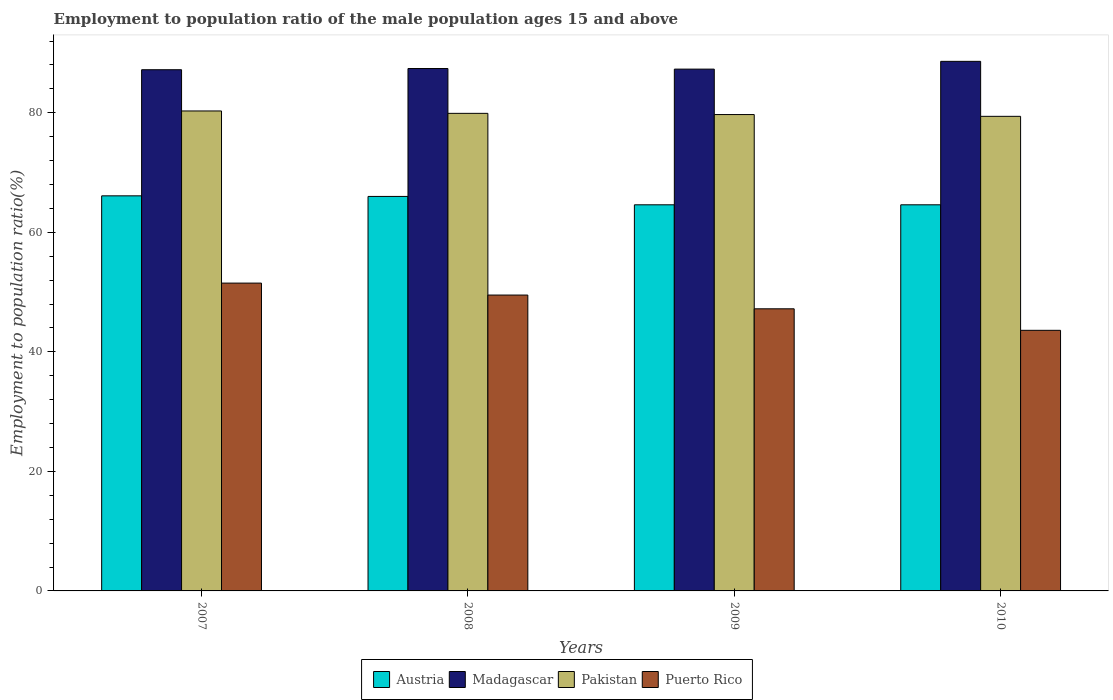How many bars are there on the 2nd tick from the left?
Provide a short and direct response. 4. How many bars are there on the 2nd tick from the right?
Keep it short and to the point. 4. In how many cases, is the number of bars for a given year not equal to the number of legend labels?
Provide a short and direct response. 0. What is the employment to population ratio in Pakistan in 2008?
Keep it short and to the point. 79.9. Across all years, what is the maximum employment to population ratio in Puerto Rico?
Ensure brevity in your answer.  51.5. Across all years, what is the minimum employment to population ratio in Madagascar?
Your answer should be very brief. 87.2. In which year was the employment to population ratio in Madagascar maximum?
Your answer should be compact. 2010. What is the total employment to population ratio in Austria in the graph?
Your answer should be compact. 261.3. What is the difference between the employment to population ratio in Madagascar in 2007 and that in 2008?
Your response must be concise. -0.2. What is the difference between the employment to population ratio in Pakistan in 2008 and the employment to population ratio in Madagascar in 2009?
Provide a succinct answer. -7.4. What is the average employment to population ratio in Puerto Rico per year?
Ensure brevity in your answer.  47.95. In the year 2010, what is the difference between the employment to population ratio in Puerto Rico and employment to population ratio in Pakistan?
Your answer should be compact. -35.8. What is the ratio of the employment to population ratio in Pakistan in 2007 to that in 2008?
Your answer should be very brief. 1.01. Is the employment to population ratio in Austria in 2007 less than that in 2010?
Keep it short and to the point. No. What is the difference between the highest and the second highest employment to population ratio in Puerto Rico?
Your answer should be compact. 2. What is the difference between the highest and the lowest employment to population ratio in Pakistan?
Provide a succinct answer. 0.9. In how many years, is the employment to population ratio in Pakistan greater than the average employment to population ratio in Pakistan taken over all years?
Provide a short and direct response. 2. Is the sum of the employment to population ratio in Madagascar in 2008 and 2009 greater than the maximum employment to population ratio in Pakistan across all years?
Your answer should be very brief. Yes. What does the 3rd bar from the right in 2010 represents?
Provide a short and direct response. Madagascar. Are all the bars in the graph horizontal?
Keep it short and to the point. No. How many years are there in the graph?
Your answer should be compact. 4. What is the difference between two consecutive major ticks on the Y-axis?
Your response must be concise. 20. Does the graph contain any zero values?
Offer a terse response. No. Does the graph contain grids?
Provide a short and direct response. No. Where does the legend appear in the graph?
Give a very brief answer. Bottom center. How many legend labels are there?
Provide a succinct answer. 4. What is the title of the graph?
Make the answer very short. Employment to population ratio of the male population ages 15 and above. Does "Low income" appear as one of the legend labels in the graph?
Make the answer very short. No. What is the Employment to population ratio(%) in Austria in 2007?
Your answer should be very brief. 66.1. What is the Employment to population ratio(%) in Madagascar in 2007?
Your answer should be very brief. 87.2. What is the Employment to population ratio(%) of Pakistan in 2007?
Make the answer very short. 80.3. What is the Employment to population ratio(%) of Puerto Rico in 2007?
Provide a short and direct response. 51.5. What is the Employment to population ratio(%) in Madagascar in 2008?
Provide a succinct answer. 87.4. What is the Employment to population ratio(%) in Pakistan in 2008?
Make the answer very short. 79.9. What is the Employment to population ratio(%) in Puerto Rico in 2008?
Your answer should be compact. 49.5. What is the Employment to population ratio(%) of Austria in 2009?
Offer a terse response. 64.6. What is the Employment to population ratio(%) of Madagascar in 2009?
Provide a short and direct response. 87.3. What is the Employment to population ratio(%) in Pakistan in 2009?
Provide a succinct answer. 79.7. What is the Employment to population ratio(%) of Puerto Rico in 2009?
Offer a terse response. 47.2. What is the Employment to population ratio(%) of Austria in 2010?
Your response must be concise. 64.6. What is the Employment to population ratio(%) of Madagascar in 2010?
Your answer should be compact. 88.6. What is the Employment to population ratio(%) of Pakistan in 2010?
Your response must be concise. 79.4. What is the Employment to population ratio(%) of Puerto Rico in 2010?
Provide a short and direct response. 43.6. Across all years, what is the maximum Employment to population ratio(%) of Austria?
Offer a terse response. 66.1. Across all years, what is the maximum Employment to population ratio(%) of Madagascar?
Offer a terse response. 88.6. Across all years, what is the maximum Employment to population ratio(%) of Pakistan?
Give a very brief answer. 80.3. Across all years, what is the maximum Employment to population ratio(%) of Puerto Rico?
Give a very brief answer. 51.5. Across all years, what is the minimum Employment to population ratio(%) of Austria?
Offer a terse response. 64.6. Across all years, what is the minimum Employment to population ratio(%) in Madagascar?
Your response must be concise. 87.2. Across all years, what is the minimum Employment to population ratio(%) in Pakistan?
Ensure brevity in your answer.  79.4. Across all years, what is the minimum Employment to population ratio(%) of Puerto Rico?
Provide a short and direct response. 43.6. What is the total Employment to population ratio(%) in Austria in the graph?
Give a very brief answer. 261.3. What is the total Employment to population ratio(%) of Madagascar in the graph?
Your response must be concise. 350.5. What is the total Employment to population ratio(%) of Pakistan in the graph?
Offer a terse response. 319.3. What is the total Employment to population ratio(%) of Puerto Rico in the graph?
Your response must be concise. 191.8. What is the difference between the Employment to population ratio(%) in Austria in 2007 and that in 2008?
Provide a short and direct response. 0.1. What is the difference between the Employment to population ratio(%) in Pakistan in 2007 and that in 2008?
Ensure brevity in your answer.  0.4. What is the difference between the Employment to population ratio(%) in Austria in 2007 and that in 2010?
Offer a very short reply. 1.5. What is the difference between the Employment to population ratio(%) in Madagascar in 2007 and that in 2010?
Make the answer very short. -1.4. What is the difference between the Employment to population ratio(%) of Puerto Rico in 2007 and that in 2010?
Offer a very short reply. 7.9. What is the difference between the Employment to population ratio(%) in Austria in 2008 and that in 2009?
Provide a succinct answer. 1.4. What is the difference between the Employment to population ratio(%) in Madagascar in 2008 and that in 2009?
Offer a very short reply. 0.1. What is the difference between the Employment to population ratio(%) in Pakistan in 2008 and that in 2009?
Offer a terse response. 0.2. What is the difference between the Employment to population ratio(%) in Austria in 2008 and that in 2010?
Ensure brevity in your answer.  1.4. What is the difference between the Employment to population ratio(%) in Puerto Rico in 2009 and that in 2010?
Provide a short and direct response. 3.6. What is the difference between the Employment to population ratio(%) in Austria in 2007 and the Employment to population ratio(%) in Madagascar in 2008?
Keep it short and to the point. -21.3. What is the difference between the Employment to population ratio(%) of Austria in 2007 and the Employment to population ratio(%) of Pakistan in 2008?
Keep it short and to the point. -13.8. What is the difference between the Employment to population ratio(%) of Austria in 2007 and the Employment to population ratio(%) of Puerto Rico in 2008?
Make the answer very short. 16.6. What is the difference between the Employment to population ratio(%) in Madagascar in 2007 and the Employment to population ratio(%) in Puerto Rico in 2008?
Your answer should be very brief. 37.7. What is the difference between the Employment to population ratio(%) in Pakistan in 2007 and the Employment to population ratio(%) in Puerto Rico in 2008?
Ensure brevity in your answer.  30.8. What is the difference between the Employment to population ratio(%) of Austria in 2007 and the Employment to population ratio(%) of Madagascar in 2009?
Provide a succinct answer. -21.2. What is the difference between the Employment to population ratio(%) in Austria in 2007 and the Employment to population ratio(%) in Pakistan in 2009?
Your answer should be very brief. -13.6. What is the difference between the Employment to population ratio(%) of Madagascar in 2007 and the Employment to population ratio(%) of Puerto Rico in 2009?
Your answer should be compact. 40. What is the difference between the Employment to population ratio(%) in Pakistan in 2007 and the Employment to population ratio(%) in Puerto Rico in 2009?
Offer a terse response. 33.1. What is the difference between the Employment to population ratio(%) in Austria in 2007 and the Employment to population ratio(%) in Madagascar in 2010?
Your response must be concise. -22.5. What is the difference between the Employment to population ratio(%) in Austria in 2007 and the Employment to population ratio(%) in Puerto Rico in 2010?
Your answer should be compact. 22.5. What is the difference between the Employment to population ratio(%) in Madagascar in 2007 and the Employment to population ratio(%) in Pakistan in 2010?
Make the answer very short. 7.8. What is the difference between the Employment to population ratio(%) of Madagascar in 2007 and the Employment to population ratio(%) of Puerto Rico in 2010?
Your answer should be very brief. 43.6. What is the difference between the Employment to population ratio(%) in Pakistan in 2007 and the Employment to population ratio(%) in Puerto Rico in 2010?
Keep it short and to the point. 36.7. What is the difference between the Employment to population ratio(%) of Austria in 2008 and the Employment to population ratio(%) of Madagascar in 2009?
Give a very brief answer. -21.3. What is the difference between the Employment to population ratio(%) in Austria in 2008 and the Employment to population ratio(%) in Pakistan in 2009?
Your answer should be very brief. -13.7. What is the difference between the Employment to population ratio(%) of Austria in 2008 and the Employment to population ratio(%) of Puerto Rico in 2009?
Give a very brief answer. 18.8. What is the difference between the Employment to population ratio(%) in Madagascar in 2008 and the Employment to population ratio(%) in Pakistan in 2009?
Give a very brief answer. 7.7. What is the difference between the Employment to population ratio(%) of Madagascar in 2008 and the Employment to population ratio(%) of Puerto Rico in 2009?
Ensure brevity in your answer.  40.2. What is the difference between the Employment to population ratio(%) in Pakistan in 2008 and the Employment to population ratio(%) in Puerto Rico in 2009?
Provide a short and direct response. 32.7. What is the difference between the Employment to population ratio(%) of Austria in 2008 and the Employment to population ratio(%) of Madagascar in 2010?
Your answer should be very brief. -22.6. What is the difference between the Employment to population ratio(%) in Austria in 2008 and the Employment to population ratio(%) in Pakistan in 2010?
Offer a terse response. -13.4. What is the difference between the Employment to population ratio(%) in Austria in 2008 and the Employment to population ratio(%) in Puerto Rico in 2010?
Offer a very short reply. 22.4. What is the difference between the Employment to population ratio(%) of Madagascar in 2008 and the Employment to population ratio(%) of Pakistan in 2010?
Provide a short and direct response. 8. What is the difference between the Employment to population ratio(%) in Madagascar in 2008 and the Employment to population ratio(%) in Puerto Rico in 2010?
Keep it short and to the point. 43.8. What is the difference between the Employment to population ratio(%) in Pakistan in 2008 and the Employment to population ratio(%) in Puerto Rico in 2010?
Offer a terse response. 36.3. What is the difference between the Employment to population ratio(%) of Austria in 2009 and the Employment to population ratio(%) of Pakistan in 2010?
Provide a succinct answer. -14.8. What is the difference between the Employment to population ratio(%) of Madagascar in 2009 and the Employment to population ratio(%) of Puerto Rico in 2010?
Your response must be concise. 43.7. What is the difference between the Employment to population ratio(%) of Pakistan in 2009 and the Employment to population ratio(%) of Puerto Rico in 2010?
Offer a very short reply. 36.1. What is the average Employment to population ratio(%) of Austria per year?
Offer a terse response. 65.33. What is the average Employment to population ratio(%) in Madagascar per year?
Offer a very short reply. 87.62. What is the average Employment to population ratio(%) in Pakistan per year?
Ensure brevity in your answer.  79.83. What is the average Employment to population ratio(%) in Puerto Rico per year?
Your response must be concise. 47.95. In the year 2007, what is the difference between the Employment to population ratio(%) of Austria and Employment to population ratio(%) of Madagascar?
Your answer should be very brief. -21.1. In the year 2007, what is the difference between the Employment to population ratio(%) in Madagascar and Employment to population ratio(%) in Puerto Rico?
Keep it short and to the point. 35.7. In the year 2007, what is the difference between the Employment to population ratio(%) of Pakistan and Employment to population ratio(%) of Puerto Rico?
Provide a short and direct response. 28.8. In the year 2008, what is the difference between the Employment to population ratio(%) in Austria and Employment to population ratio(%) in Madagascar?
Make the answer very short. -21.4. In the year 2008, what is the difference between the Employment to population ratio(%) of Madagascar and Employment to population ratio(%) of Pakistan?
Provide a succinct answer. 7.5. In the year 2008, what is the difference between the Employment to population ratio(%) of Madagascar and Employment to population ratio(%) of Puerto Rico?
Keep it short and to the point. 37.9. In the year 2008, what is the difference between the Employment to population ratio(%) in Pakistan and Employment to population ratio(%) in Puerto Rico?
Provide a succinct answer. 30.4. In the year 2009, what is the difference between the Employment to population ratio(%) in Austria and Employment to population ratio(%) in Madagascar?
Offer a very short reply. -22.7. In the year 2009, what is the difference between the Employment to population ratio(%) of Austria and Employment to population ratio(%) of Pakistan?
Offer a terse response. -15.1. In the year 2009, what is the difference between the Employment to population ratio(%) of Austria and Employment to population ratio(%) of Puerto Rico?
Provide a succinct answer. 17.4. In the year 2009, what is the difference between the Employment to population ratio(%) of Madagascar and Employment to population ratio(%) of Pakistan?
Offer a terse response. 7.6. In the year 2009, what is the difference between the Employment to population ratio(%) in Madagascar and Employment to population ratio(%) in Puerto Rico?
Offer a terse response. 40.1. In the year 2009, what is the difference between the Employment to population ratio(%) in Pakistan and Employment to population ratio(%) in Puerto Rico?
Keep it short and to the point. 32.5. In the year 2010, what is the difference between the Employment to population ratio(%) of Austria and Employment to population ratio(%) of Madagascar?
Provide a short and direct response. -24. In the year 2010, what is the difference between the Employment to population ratio(%) in Austria and Employment to population ratio(%) in Pakistan?
Make the answer very short. -14.8. In the year 2010, what is the difference between the Employment to population ratio(%) in Austria and Employment to population ratio(%) in Puerto Rico?
Offer a terse response. 21. In the year 2010, what is the difference between the Employment to population ratio(%) in Madagascar and Employment to population ratio(%) in Pakistan?
Provide a short and direct response. 9.2. In the year 2010, what is the difference between the Employment to population ratio(%) in Madagascar and Employment to population ratio(%) in Puerto Rico?
Offer a terse response. 45. In the year 2010, what is the difference between the Employment to population ratio(%) in Pakistan and Employment to population ratio(%) in Puerto Rico?
Give a very brief answer. 35.8. What is the ratio of the Employment to population ratio(%) of Madagascar in 2007 to that in 2008?
Make the answer very short. 1. What is the ratio of the Employment to population ratio(%) of Puerto Rico in 2007 to that in 2008?
Offer a very short reply. 1.04. What is the ratio of the Employment to population ratio(%) in Austria in 2007 to that in 2009?
Ensure brevity in your answer.  1.02. What is the ratio of the Employment to population ratio(%) in Pakistan in 2007 to that in 2009?
Provide a succinct answer. 1.01. What is the ratio of the Employment to population ratio(%) in Puerto Rico in 2007 to that in 2009?
Ensure brevity in your answer.  1.09. What is the ratio of the Employment to population ratio(%) of Austria in 2007 to that in 2010?
Keep it short and to the point. 1.02. What is the ratio of the Employment to population ratio(%) in Madagascar in 2007 to that in 2010?
Provide a short and direct response. 0.98. What is the ratio of the Employment to population ratio(%) in Pakistan in 2007 to that in 2010?
Keep it short and to the point. 1.01. What is the ratio of the Employment to population ratio(%) of Puerto Rico in 2007 to that in 2010?
Your response must be concise. 1.18. What is the ratio of the Employment to population ratio(%) of Austria in 2008 to that in 2009?
Your response must be concise. 1.02. What is the ratio of the Employment to population ratio(%) in Puerto Rico in 2008 to that in 2009?
Keep it short and to the point. 1.05. What is the ratio of the Employment to population ratio(%) in Austria in 2008 to that in 2010?
Ensure brevity in your answer.  1.02. What is the ratio of the Employment to population ratio(%) of Madagascar in 2008 to that in 2010?
Offer a very short reply. 0.99. What is the ratio of the Employment to population ratio(%) in Pakistan in 2008 to that in 2010?
Offer a terse response. 1.01. What is the ratio of the Employment to population ratio(%) in Puerto Rico in 2008 to that in 2010?
Give a very brief answer. 1.14. What is the ratio of the Employment to population ratio(%) of Puerto Rico in 2009 to that in 2010?
Provide a short and direct response. 1.08. What is the difference between the highest and the second highest Employment to population ratio(%) in Austria?
Keep it short and to the point. 0.1. What is the difference between the highest and the second highest Employment to population ratio(%) of Puerto Rico?
Your answer should be compact. 2. 